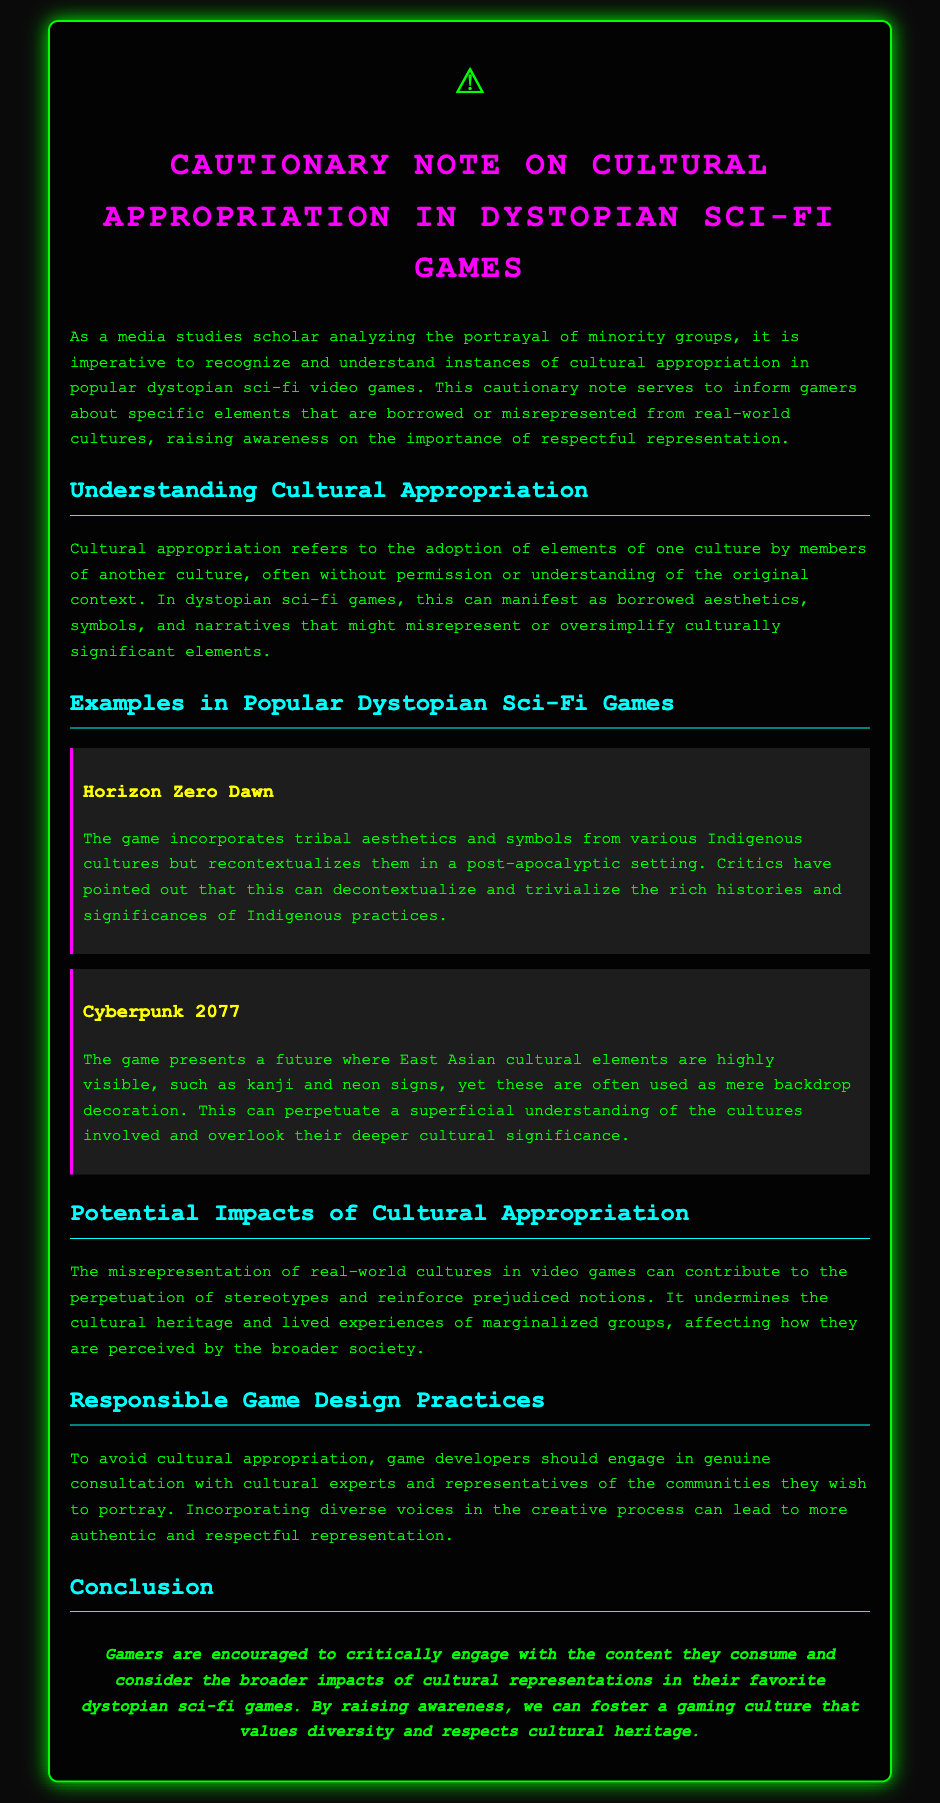What is the title of the document? The title is prominently displayed at the top of the document, which is “Cautionary Note on Cultural Appropriation in Dystopian Sci-Fi Games.”
Answer: Cautionary Note on Cultural Appropriation in Dystopian Sci-Fi Games What symbol is displayed at the top of the document? The document features a warning symbol, which is represented by an emoji.
Answer: ⚠️ What game is mentioned as an example that incorporates tribal aesthetics? The document describes a specific game that incorporates tribal aesthetics in its design.
Answer: Horizon Zero Dawn What should game developers engage in to avoid cultural appropriation? The document outlines a recommended practice for game developers to ensure respectful representation of cultures.
Answer: Genuine consultation What can misrepresentation in video games contribute to? The document discusses several potential negative outcomes of cultural misrepresentation in video games.
Answer: Stereotypes What color scheme does the body of the document use? The document's body color scheme can be inferred from the description of the text and background colors.
Answer: Black and green How does the document suggest gamers should engage with the content? The conclusion emphasizes a particular way for gamers to interact with the media they consume.
Answer: Critically What are the consequences of misrepresenting real-world cultures? The document explains the implications of cultural misrepresentation, particularly regarding societal perceptions.
Answer: Reinforce prejudiced notions 